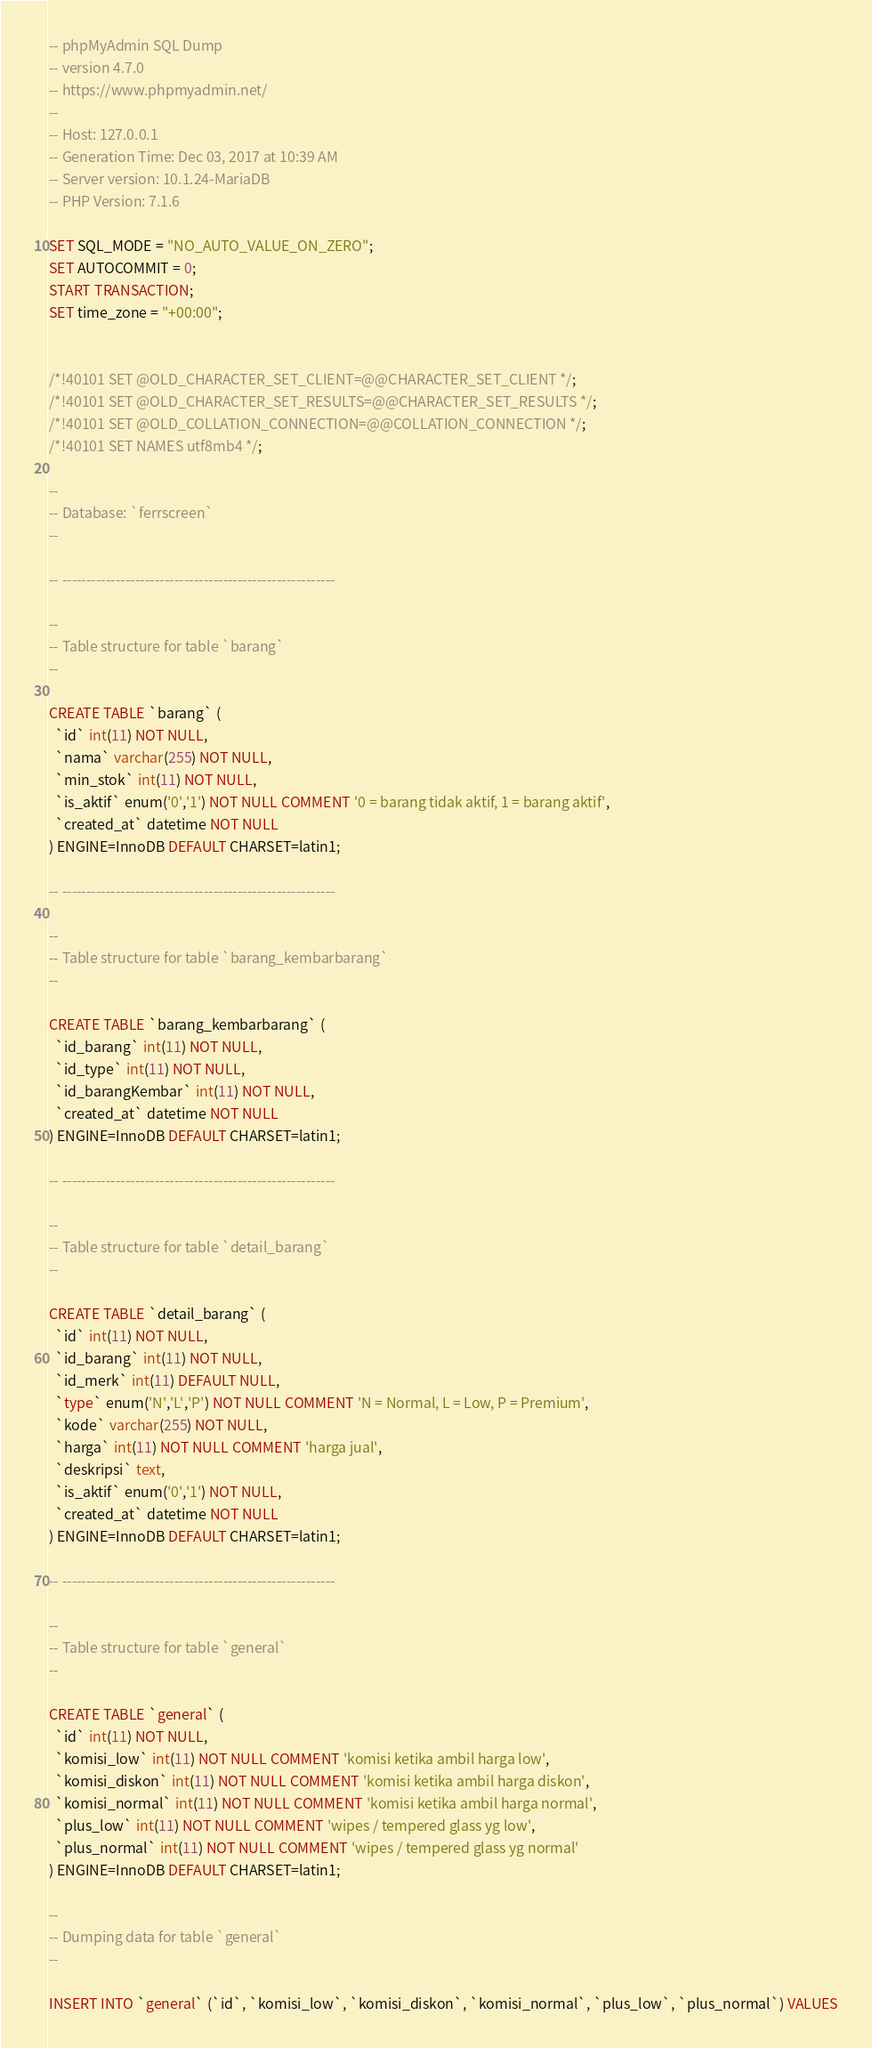<code> <loc_0><loc_0><loc_500><loc_500><_SQL_>-- phpMyAdmin SQL Dump
-- version 4.7.0
-- https://www.phpmyadmin.net/
--
-- Host: 127.0.0.1
-- Generation Time: Dec 03, 2017 at 10:39 AM
-- Server version: 10.1.24-MariaDB
-- PHP Version: 7.1.6

SET SQL_MODE = "NO_AUTO_VALUE_ON_ZERO";
SET AUTOCOMMIT = 0;
START TRANSACTION;
SET time_zone = "+00:00";


/*!40101 SET @OLD_CHARACTER_SET_CLIENT=@@CHARACTER_SET_CLIENT */;
/*!40101 SET @OLD_CHARACTER_SET_RESULTS=@@CHARACTER_SET_RESULTS */;
/*!40101 SET @OLD_COLLATION_CONNECTION=@@COLLATION_CONNECTION */;
/*!40101 SET NAMES utf8mb4 */;

--
-- Database: `ferrscreen`
--

-- --------------------------------------------------------

--
-- Table structure for table `barang`
--

CREATE TABLE `barang` (
  `id` int(11) NOT NULL,
  `nama` varchar(255) NOT NULL,
  `min_stok` int(11) NOT NULL,
  `is_aktif` enum('0','1') NOT NULL COMMENT '0 = barang tidak aktif, 1 = barang aktif',
  `created_at` datetime NOT NULL
) ENGINE=InnoDB DEFAULT CHARSET=latin1;

-- --------------------------------------------------------

--
-- Table structure for table `barang_kembarbarang`
--

CREATE TABLE `barang_kembarbarang` (
  `id_barang` int(11) NOT NULL,
  `id_type` int(11) NOT NULL,
  `id_barangKembar` int(11) NOT NULL,
  `created_at` datetime NOT NULL
) ENGINE=InnoDB DEFAULT CHARSET=latin1;

-- --------------------------------------------------------

--
-- Table structure for table `detail_barang`
--

CREATE TABLE `detail_barang` (
  `id` int(11) NOT NULL,
  `id_barang` int(11) NOT NULL,
  `id_merk` int(11) DEFAULT NULL,
  `type` enum('N','L','P') NOT NULL COMMENT 'N = Normal, L = Low, P = Premium',
  `kode` varchar(255) NOT NULL,
  `harga` int(11) NOT NULL COMMENT 'harga jual',
  `deskripsi` text,
  `is_aktif` enum('0','1') NOT NULL,
  `created_at` datetime NOT NULL
) ENGINE=InnoDB DEFAULT CHARSET=latin1;

-- --------------------------------------------------------

--
-- Table structure for table `general`
--

CREATE TABLE `general` (
  `id` int(11) NOT NULL,
  `komisi_low` int(11) NOT NULL COMMENT 'komisi ketika ambil harga low',
  `komisi_diskon` int(11) NOT NULL COMMENT 'komisi ketika ambil harga diskon',
  `komisi_normal` int(11) NOT NULL COMMENT 'komisi ketika ambil harga normal',
  `plus_low` int(11) NOT NULL COMMENT 'wipes / tempered glass yg low',
  `plus_normal` int(11) NOT NULL COMMENT 'wipes / tempered glass yg normal'
) ENGINE=InnoDB DEFAULT CHARSET=latin1;

--
-- Dumping data for table `general`
--

INSERT INTO `general` (`id`, `komisi_low`, `komisi_diskon`, `komisi_normal`, `plus_low`, `plus_normal`) VALUES</code> 